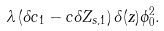<formula> <loc_0><loc_0><loc_500><loc_500>\lambda \left ( \delta c _ { 1 } - c \delta Z _ { s , 1 } \right ) \delta ( z ) \phi _ { 0 } ^ { 2 } .</formula> 